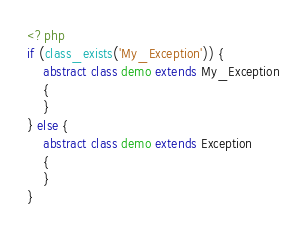<code> <loc_0><loc_0><loc_500><loc_500><_PHP_><?php
if (class_exists('My_Exception')) {
    abstract class demo extends My_Exception
    {
    }
} else {
    abstract class demo extends Exception
    {
    }
}</code> 